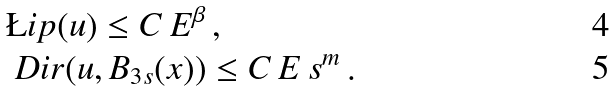<formula> <loc_0><loc_0><loc_500><loc_500>& \L i p ( u ) \leq C \, E ^ { \beta } \, , \\ & \ D i r ( u , B _ { 3 s } ( x ) ) \leq C \, E \, s ^ { m } \, .</formula> 